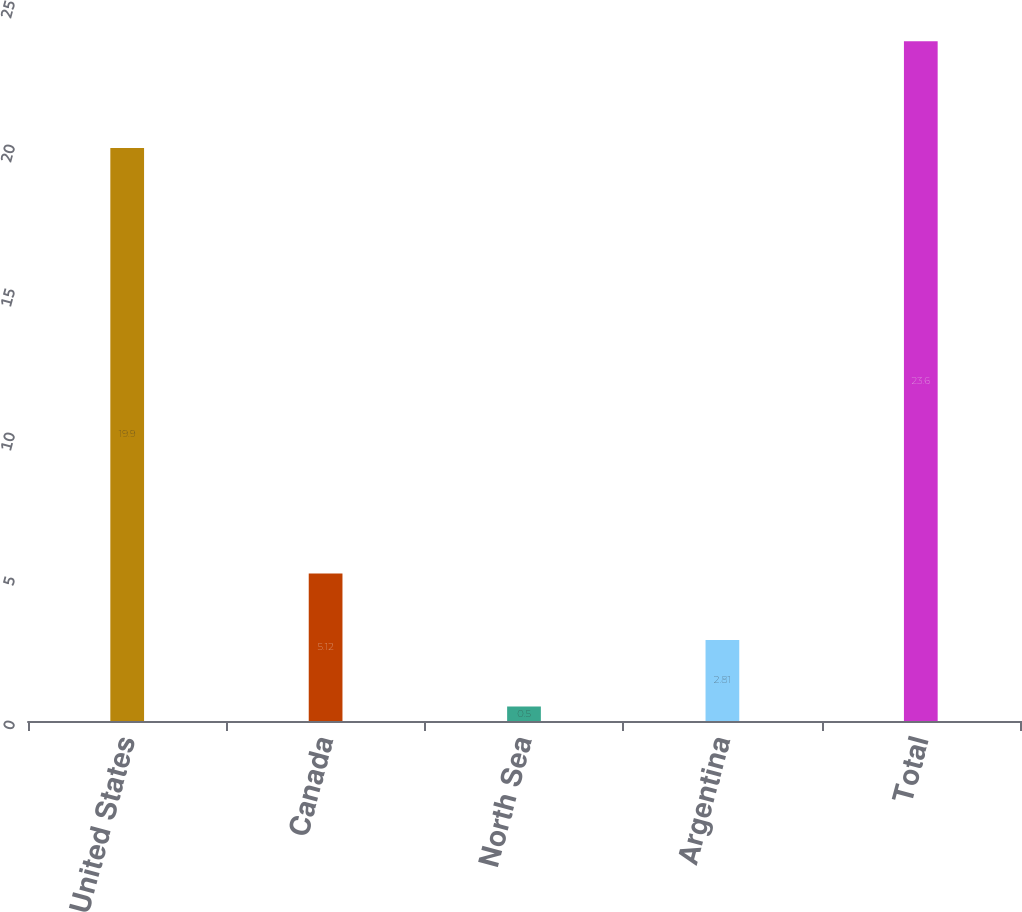<chart> <loc_0><loc_0><loc_500><loc_500><bar_chart><fcel>United States<fcel>Canada<fcel>North Sea<fcel>Argentina<fcel>Total<nl><fcel>19.9<fcel>5.12<fcel>0.5<fcel>2.81<fcel>23.6<nl></chart> 